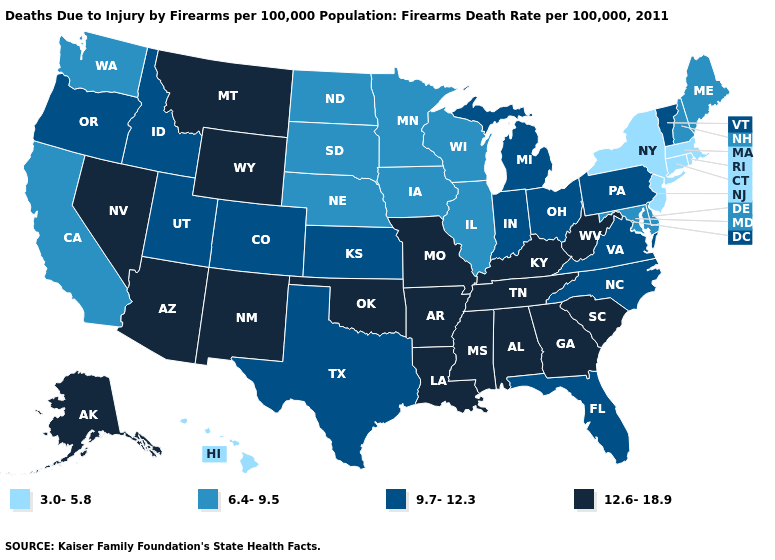What is the value of Kansas?
Give a very brief answer. 9.7-12.3. Among the states that border Ohio , which have the highest value?
Be succinct. Kentucky, West Virginia. What is the value of Connecticut?
Concise answer only. 3.0-5.8. Name the states that have a value in the range 9.7-12.3?
Answer briefly. Colorado, Florida, Idaho, Indiana, Kansas, Michigan, North Carolina, Ohio, Oregon, Pennsylvania, Texas, Utah, Vermont, Virginia. What is the value of Connecticut?
Concise answer only. 3.0-5.8. Name the states that have a value in the range 6.4-9.5?
Write a very short answer. California, Delaware, Illinois, Iowa, Maine, Maryland, Minnesota, Nebraska, New Hampshire, North Dakota, South Dakota, Washington, Wisconsin. Name the states that have a value in the range 9.7-12.3?
Quick response, please. Colorado, Florida, Idaho, Indiana, Kansas, Michigan, North Carolina, Ohio, Oregon, Pennsylvania, Texas, Utah, Vermont, Virginia. Does Colorado have the same value as West Virginia?
Quick response, please. No. Does Pennsylvania have a lower value than Tennessee?
Keep it brief. Yes. Does the map have missing data?
Concise answer only. No. Does Delaware have the lowest value in the USA?
Answer briefly. No. How many symbols are there in the legend?
Give a very brief answer. 4. Which states hav the highest value in the Northeast?
Be succinct. Pennsylvania, Vermont. What is the highest value in the USA?
Keep it brief. 12.6-18.9. Does Iowa have a higher value than New Jersey?
Give a very brief answer. Yes. 